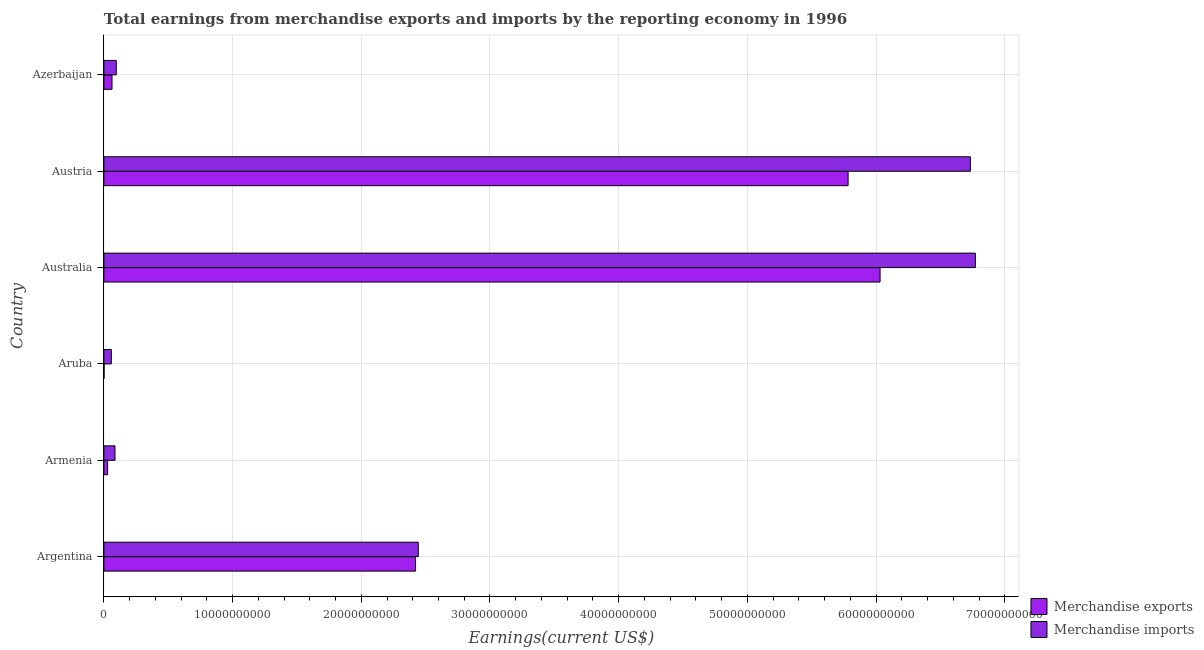How many different coloured bars are there?
Make the answer very short. 2. How many bars are there on the 3rd tick from the top?
Your answer should be very brief. 2. How many bars are there on the 2nd tick from the bottom?
Your answer should be compact. 2. What is the label of the 5th group of bars from the top?
Offer a terse response. Armenia. In how many cases, is the number of bars for a given country not equal to the number of legend labels?
Ensure brevity in your answer.  0. What is the earnings from merchandise exports in Azerbaijan?
Provide a succinct answer. 6.31e+08. Across all countries, what is the maximum earnings from merchandise imports?
Provide a short and direct response. 6.77e+1. Across all countries, what is the minimum earnings from merchandise exports?
Your answer should be compact. 1.25e+07. In which country was the earnings from merchandise exports maximum?
Make the answer very short. Australia. In which country was the earnings from merchandise imports minimum?
Your answer should be very brief. Aruba. What is the total earnings from merchandise imports in the graph?
Your response must be concise. 1.62e+11. What is the difference between the earnings from merchandise exports in Aruba and that in Azerbaijan?
Offer a terse response. -6.19e+08. What is the difference between the earnings from merchandise exports in Azerbaijan and the earnings from merchandise imports in Aruba?
Provide a succinct answer. 5.30e+07. What is the average earnings from merchandise imports per country?
Your answer should be compact. 2.70e+1. What is the difference between the earnings from merchandise exports and earnings from merchandise imports in Azerbaijan?
Give a very brief answer. -3.29e+08. In how many countries, is the earnings from merchandise exports greater than 68000000000 US$?
Offer a very short reply. 0. What is the ratio of the earnings from merchandise imports in Austria to that in Azerbaijan?
Your response must be concise. 70.09. Is the earnings from merchandise exports in Australia less than that in Azerbaijan?
Offer a terse response. No. What is the difference between the highest and the second highest earnings from merchandise exports?
Give a very brief answer. 2.48e+09. What is the difference between the highest and the lowest earnings from merchandise exports?
Provide a short and direct response. 6.03e+1. In how many countries, is the earnings from merchandise exports greater than the average earnings from merchandise exports taken over all countries?
Your response must be concise. 3. What does the 1st bar from the bottom in Austria represents?
Offer a very short reply. Merchandise exports. How many bars are there?
Provide a succinct answer. 12. Are all the bars in the graph horizontal?
Give a very brief answer. Yes. What is the difference between two consecutive major ticks on the X-axis?
Your response must be concise. 1.00e+1. How many legend labels are there?
Make the answer very short. 2. What is the title of the graph?
Provide a short and direct response. Total earnings from merchandise exports and imports by the reporting economy in 1996. Does "Subsidies" appear as one of the legend labels in the graph?
Your answer should be very brief. No. What is the label or title of the X-axis?
Keep it short and to the point. Earnings(current US$). What is the label or title of the Y-axis?
Provide a short and direct response. Country. What is the Earnings(current US$) in Merchandise exports in Argentina?
Make the answer very short. 2.42e+1. What is the Earnings(current US$) in Merchandise imports in Argentina?
Offer a terse response. 2.44e+1. What is the Earnings(current US$) of Merchandise exports in Armenia?
Offer a very short reply. 2.90e+08. What is the Earnings(current US$) of Merchandise imports in Armenia?
Offer a terse response. 8.62e+08. What is the Earnings(current US$) of Merchandise exports in Aruba?
Keep it short and to the point. 1.25e+07. What is the Earnings(current US$) in Merchandise imports in Aruba?
Provide a succinct answer. 5.78e+08. What is the Earnings(current US$) in Merchandise exports in Australia?
Keep it short and to the point. 6.03e+1. What is the Earnings(current US$) in Merchandise imports in Australia?
Ensure brevity in your answer.  6.77e+1. What is the Earnings(current US$) of Merchandise exports in Austria?
Your answer should be compact. 5.78e+1. What is the Earnings(current US$) in Merchandise imports in Austria?
Your response must be concise. 6.73e+1. What is the Earnings(current US$) of Merchandise exports in Azerbaijan?
Provide a short and direct response. 6.31e+08. What is the Earnings(current US$) of Merchandise imports in Azerbaijan?
Keep it short and to the point. 9.61e+08. Across all countries, what is the maximum Earnings(current US$) of Merchandise exports?
Your response must be concise. 6.03e+1. Across all countries, what is the maximum Earnings(current US$) in Merchandise imports?
Your answer should be very brief. 6.77e+1. Across all countries, what is the minimum Earnings(current US$) in Merchandise exports?
Your response must be concise. 1.25e+07. Across all countries, what is the minimum Earnings(current US$) in Merchandise imports?
Offer a terse response. 5.78e+08. What is the total Earnings(current US$) in Merchandise exports in the graph?
Keep it short and to the point. 1.43e+11. What is the total Earnings(current US$) in Merchandise imports in the graph?
Offer a terse response. 1.62e+11. What is the difference between the Earnings(current US$) in Merchandise exports in Argentina and that in Armenia?
Make the answer very short. 2.39e+1. What is the difference between the Earnings(current US$) in Merchandise imports in Argentina and that in Armenia?
Your answer should be compact. 2.36e+1. What is the difference between the Earnings(current US$) in Merchandise exports in Argentina and that in Aruba?
Keep it short and to the point. 2.42e+1. What is the difference between the Earnings(current US$) of Merchandise imports in Argentina and that in Aruba?
Your answer should be very brief. 2.38e+1. What is the difference between the Earnings(current US$) of Merchandise exports in Argentina and that in Australia?
Provide a succinct answer. -3.61e+1. What is the difference between the Earnings(current US$) in Merchandise imports in Argentina and that in Australia?
Your answer should be very brief. -4.33e+1. What is the difference between the Earnings(current US$) in Merchandise exports in Argentina and that in Austria?
Provide a short and direct response. -3.36e+1. What is the difference between the Earnings(current US$) in Merchandise imports in Argentina and that in Austria?
Provide a succinct answer. -4.29e+1. What is the difference between the Earnings(current US$) in Merchandise exports in Argentina and that in Azerbaijan?
Offer a terse response. 2.36e+1. What is the difference between the Earnings(current US$) in Merchandise imports in Argentina and that in Azerbaijan?
Give a very brief answer. 2.35e+1. What is the difference between the Earnings(current US$) of Merchandise exports in Armenia and that in Aruba?
Make the answer very short. 2.78e+08. What is the difference between the Earnings(current US$) in Merchandise imports in Armenia and that in Aruba?
Offer a very short reply. 2.83e+08. What is the difference between the Earnings(current US$) in Merchandise exports in Armenia and that in Australia?
Provide a succinct answer. -6.00e+1. What is the difference between the Earnings(current US$) in Merchandise imports in Armenia and that in Australia?
Your response must be concise. -6.69e+1. What is the difference between the Earnings(current US$) in Merchandise exports in Armenia and that in Austria?
Offer a terse response. -5.75e+1. What is the difference between the Earnings(current US$) of Merchandise imports in Armenia and that in Austria?
Provide a succinct answer. -6.65e+1. What is the difference between the Earnings(current US$) of Merchandise exports in Armenia and that in Azerbaijan?
Give a very brief answer. -3.41e+08. What is the difference between the Earnings(current US$) in Merchandise imports in Armenia and that in Azerbaijan?
Your answer should be very brief. -9.91e+07. What is the difference between the Earnings(current US$) of Merchandise exports in Aruba and that in Australia?
Your answer should be very brief. -6.03e+1. What is the difference between the Earnings(current US$) in Merchandise imports in Aruba and that in Australia?
Offer a terse response. -6.71e+1. What is the difference between the Earnings(current US$) in Merchandise exports in Aruba and that in Austria?
Ensure brevity in your answer.  -5.78e+1. What is the difference between the Earnings(current US$) of Merchandise imports in Aruba and that in Austria?
Make the answer very short. -6.67e+1. What is the difference between the Earnings(current US$) of Merchandise exports in Aruba and that in Azerbaijan?
Your answer should be compact. -6.19e+08. What is the difference between the Earnings(current US$) of Merchandise imports in Aruba and that in Azerbaijan?
Make the answer very short. -3.82e+08. What is the difference between the Earnings(current US$) of Merchandise exports in Australia and that in Austria?
Ensure brevity in your answer.  2.48e+09. What is the difference between the Earnings(current US$) in Merchandise imports in Australia and that in Austria?
Offer a very short reply. 3.90e+08. What is the difference between the Earnings(current US$) in Merchandise exports in Australia and that in Azerbaijan?
Give a very brief answer. 5.97e+1. What is the difference between the Earnings(current US$) in Merchandise imports in Australia and that in Azerbaijan?
Offer a terse response. 6.68e+1. What is the difference between the Earnings(current US$) in Merchandise exports in Austria and that in Azerbaijan?
Your answer should be compact. 5.72e+1. What is the difference between the Earnings(current US$) of Merchandise imports in Austria and that in Azerbaijan?
Make the answer very short. 6.64e+1. What is the difference between the Earnings(current US$) in Merchandise exports in Argentina and the Earnings(current US$) in Merchandise imports in Armenia?
Your answer should be very brief. 2.34e+1. What is the difference between the Earnings(current US$) of Merchandise exports in Argentina and the Earnings(current US$) of Merchandise imports in Aruba?
Keep it short and to the point. 2.36e+1. What is the difference between the Earnings(current US$) in Merchandise exports in Argentina and the Earnings(current US$) in Merchandise imports in Australia?
Give a very brief answer. -4.35e+1. What is the difference between the Earnings(current US$) of Merchandise exports in Argentina and the Earnings(current US$) of Merchandise imports in Austria?
Make the answer very short. -4.31e+1. What is the difference between the Earnings(current US$) of Merchandise exports in Argentina and the Earnings(current US$) of Merchandise imports in Azerbaijan?
Provide a short and direct response. 2.33e+1. What is the difference between the Earnings(current US$) of Merchandise exports in Armenia and the Earnings(current US$) of Merchandise imports in Aruba?
Offer a terse response. -2.88e+08. What is the difference between the Earnings(current US$) in Merchandise exports in Armenia and the Earnings(current US$) in Merchandise imports in Australia?
Your answer should be compact. -6.74e+1. What is the difference between the Earnings(current US$) in Merchandise exports in Armenia and the Earnings(current US$) in Merchandise imports in Austria?
Provide a succinct answer. -6.70e+1. What is the difference between the Earnings(current US$) of Merchandise exports in Armenia and the Earnings(current US$) of Merchandise imports in Azerbaijan?
Give a very brief answer. -6.70e+08. What is the difference between the Earnings(current US$) in Merchandise exports in Aruba and the Earnings(current US$) in Merchandise imports in Australia?
Ensure brevity in your answer.  -6.77e+1. What is the difference between the Earnings(current US$) in Merchandise exports in Aruba and the Earnings(current US$) in Merchandise imports in Austria?
Give a very brief answer. -6.73e+1. What is the difference between the Earnings(current US$) of Merchandise exports in Aruba and the Earnings(current US$) of Merchandise imports in Azerbaijan?
Make the answer very short. -9.48e+08. What is the difference between the Earnings(current US$) of Merchandise exports in Australia and the Earnings(current US$) of Merchandise imports in Austria?
Give a very brief answer. -7.02e+09. What is the difference between the Earnings(current US$) of Merchandise exports in Australia and the Earnings(current US$) of Merchandise imports in Azerbaijan?
Keep it short and to the point. 5.93e+1. What is the difference between the Earnings(current US$) in Merchandise exports in Austria and the Earnings(current US$) in Merchandise imports in Azerbaijan?
Make the answer very short. 5.69e+1. What is the average Earnings(current US$) in Merchandise exports per country?
Keep it short and to the point. 2.39e+1. What is the average Earnings(current US$) in Merchandise imports per country?
Offer a very short reply. 2.70e+1. What is the difference between the Earnings(current US$) in Merchandise exports and Earnings(current US$) in Merchandise imports in Argentina?
Ensure brevity in your answer.  -2.11e+08. What is the difference between the Earnings(current US$) of Merchandise exports and Earnings(current US$) of Merchandise imports in Armenia?
Ensure brevity in your answer.  -5.71e+08. What is the difference between the Earnings(current US$) of Merchandise exports and Earnings(current US$) of Merchandise imports in Aruba?
Provide a succinct answer. -5.66e+08. What is the difference between the Earnings(current US$) of Merchandise exports and Earnings(current US$) of Merchandise imports in Australia?
Your answer should be very brief. -7.41e+09. What is the difference between the Earnings(current US$) in Merchandise exports and Earnings(current US$) in Merchandise imports in Austria?
Ensure brevity in your answer.  -9.50e+09. What is the difference between the Earnings(current US$) of Merchandise exports and Earnings(current US$) of Merchandise imports in Azerbaijan?
Your answer should be compact. -3.29e+08. What is the ratio of the Earnings(current US$) of Merchandise exports in Argentina to that in Armenia?
Offer a terse response. 83.42. What is the ratio of the Earnings(current US$) of Merchandise imports in Argentina to that in Armenia?
Make the answer very short. 28.35. What is the ratio of the Earnings(current US$) of Merchandise exports in Argentina to that in Aruba?
Provide a succinct answer. 1932.72. What is the ratio of the Earnings(current US$) of Merchandise imports in Argentina to that in Aruba?
Keep it short and to the point. 42.25. What is the ratio of the Earnings(current US$) of Merchandise exports in Argentina to that in Australia?
Provide a short and direct response. 0.4. What is the ratio of the Earnings(current US$) in Merchandise imports in Argentina to that in Australia?
Keep it short and to the point. 0.36. What is the ratio of the Earnings(current US$) of Merchandise exports in Argentina to that in Austria?
Keep it short and to the point. 0.42. What is the ratio of the Earnings(current US$) of Merchandise imports in Argentina to that in Austria?
Provide a short and direct response. 0.36. What is the ratio of the Earnings(current US$) in Merchandise exports in Argentina to that in Azerbaijan?
Your answer should be compact. 38.36. What is the ratio of the Earnings(current US$) of Merchandise imports in Argentina to that in Azerbaijan?
Offer a very short reply. 25.43. What is the ratio of the Earnings(current US$) in Merchandise exports in Armenia to that in Aruba?
Your response must be concise. 23.17. What is the ratio of the Earnings(current US$) in Merchandise imports in Armenia to that in Aruba?
Provide a succinct answer. 1.49. What is the ratio of the Earnings(current US$) of Merchandise exports in Armenia to that in Australia?
Your answer should be compact. 0. What is the ratio of the Earnings(current US$) in Merchandise imports in Armenia to that in Australia?
Provide a succinct answer. 0.01. What is the ratio of the Earnings(current US$) in Merchandise exports in Armenia to that in Austria?
Keep it short and to the point. 0.01. What is the ratio of the Earnings(current US$) of Merchandise imports in Armenia to that in Austria?
Provide a short and direct response. 0.01. What is the ratio of the Earnings(current US$) of Merchandise exports in Armenia to that in Azerbaijan?
Keep it short and to the point. 0.46. What is the ratio of the Earnings(current US$) in Merchandise imports in Armenia to that in Azerbaijan?
Provide a short and direct response. 0.9. What is the ratio of the Earnings(current US$) in Merchandise imports in Aruba to that in Australia?
Give a very brief answer. 0.01. What is the ratio of the Earnings(current US$) of Merchandise exports in Aruba to that in Austria?
Offer a terse response. 0. What is the ratio of the Earnings(current US$) in Merchandise imports in Aruba to that in Austria?
Make the answer very short. 0.01. What is the ratio of the Earnings(current US$) of Merchandise exports in Aruba to that in Azerbaijan?
Offer a terse response. 0.02. What is the ratio of the Earnings(current US$) in Merchandise imports in Aruba to that in Azerbaijan?
Provide a succinct answer. 0.6. What is the ratio of the Earnings(current US$) of Merchandise exports in Australia to that in Austria?
Your response must be concise. 1.04. What is the ratio of the Earnings(current US$) of Merchandise imports in Australia to that in Austria?
Give a very brief answer. 1.01. What is the ratio of the Earnings(current US$) of Merchandise exports in Australia to that in Azerbaijan?
Keep it short and to the point. 95.54. What is the ratio of the Earnings(current US$) of Merchandise imports in Australia to that in Azerbaijan?
Your answer should be compact. 70.49. What is the ratio of the Earnings(current US$) of Merchandise exports in Austria to that in Azerbaijan?
Your response must be concise. 91.61. What is the ratio of the Earnings(current US$) in Merchandise imports in Austria to that in Azerbaijan?
Your answer should be very brief. 70.09. What is the difference between the highest and the second highest Earnings(current US$) in Merchandise exports?
Make the answer very short. 2.48e+09. What is the difference between the highest and the second highest Earnings(current US$) of Merchandise imports?
Give a very brief answer. 3.90e+08. What is the difference between the highest and the lowest Earnings(current US$) of Merchandise exports?
Your answer should be very brief. 6.03e+1. What is the difference between the highest and the lowest Earnings(current US$) of Merchandise imports?
Make the answer very short. 6.71e+1. 